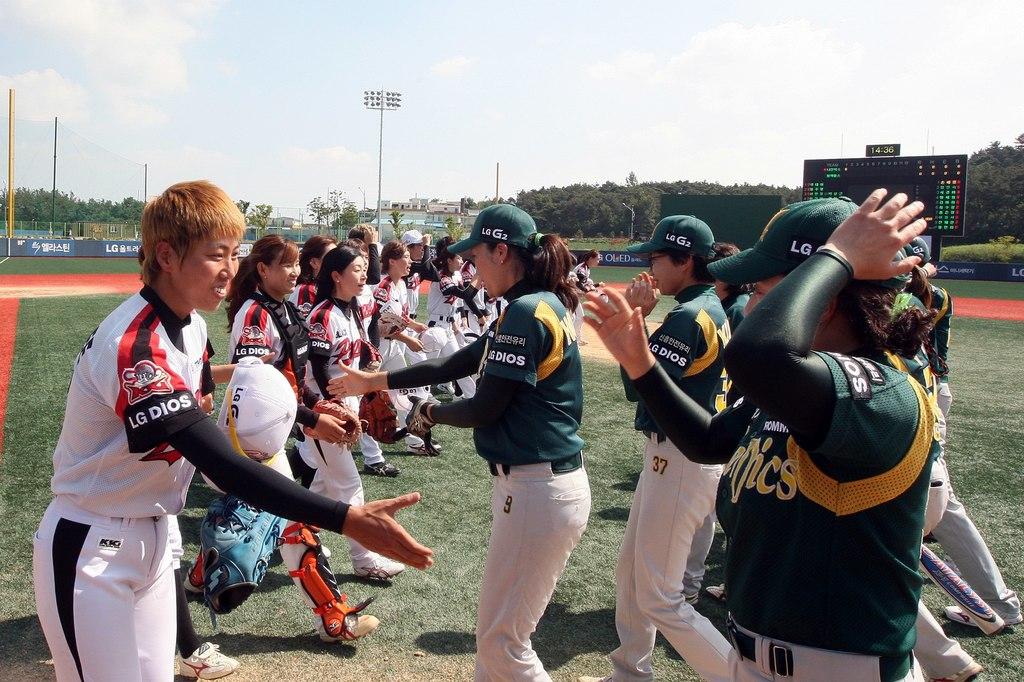What is written on the sleeves of the players in white?
Provide a succinct answer. Lg dios. 